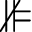<formula> <loc_0><loc_0><loc_500><loc_500>\nVDash</formula> 